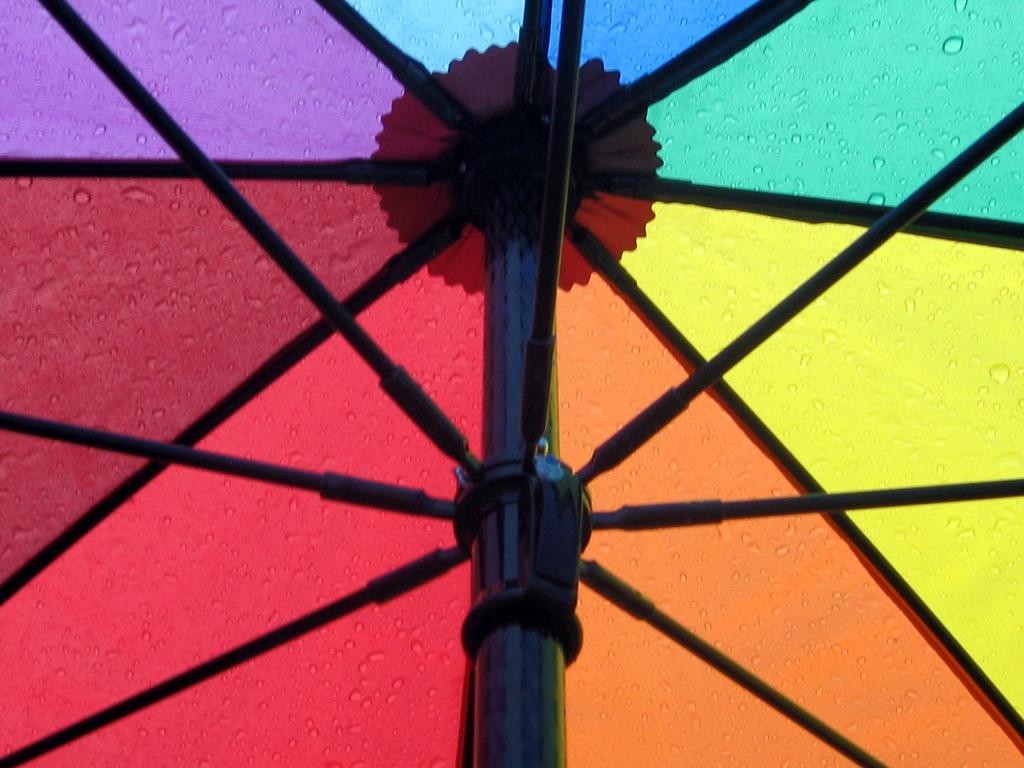Please provide a concise description of this image. In this image, I can see metal rods and a colorful background. This picture taken in a day. 